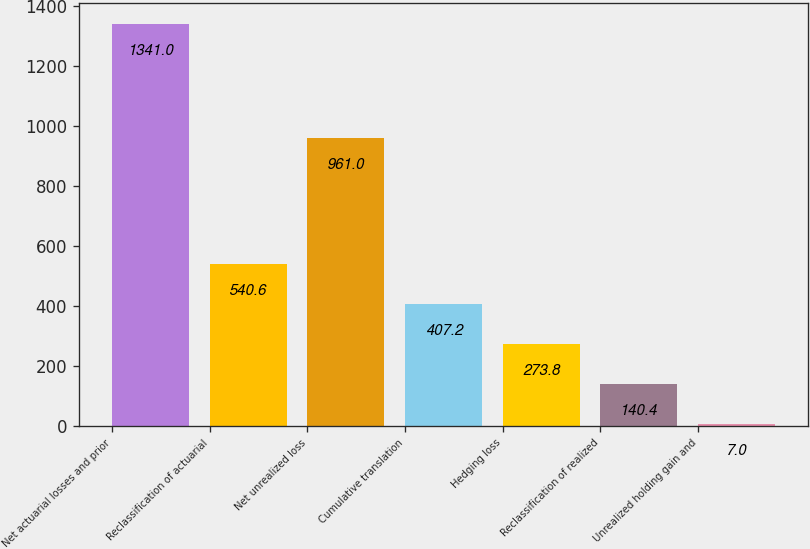<chart> <loc_0><loc_0><loc_500><loc_500><bar_chart><fcel>Net actuarial losses and prior<fcel>Reclassification of actuarial<fcel>Net unrealized loss<fcel>Cumulative translation<fcel>Hedging loss<fcel>Reclassification of realized<fcel>Unrealized holding gain and<nl><fcel>1341<fcel>540.6<fcel>961<fcel>407.2<fcel>273.8<fcel>140.4<fcel>7<nl></chart> 